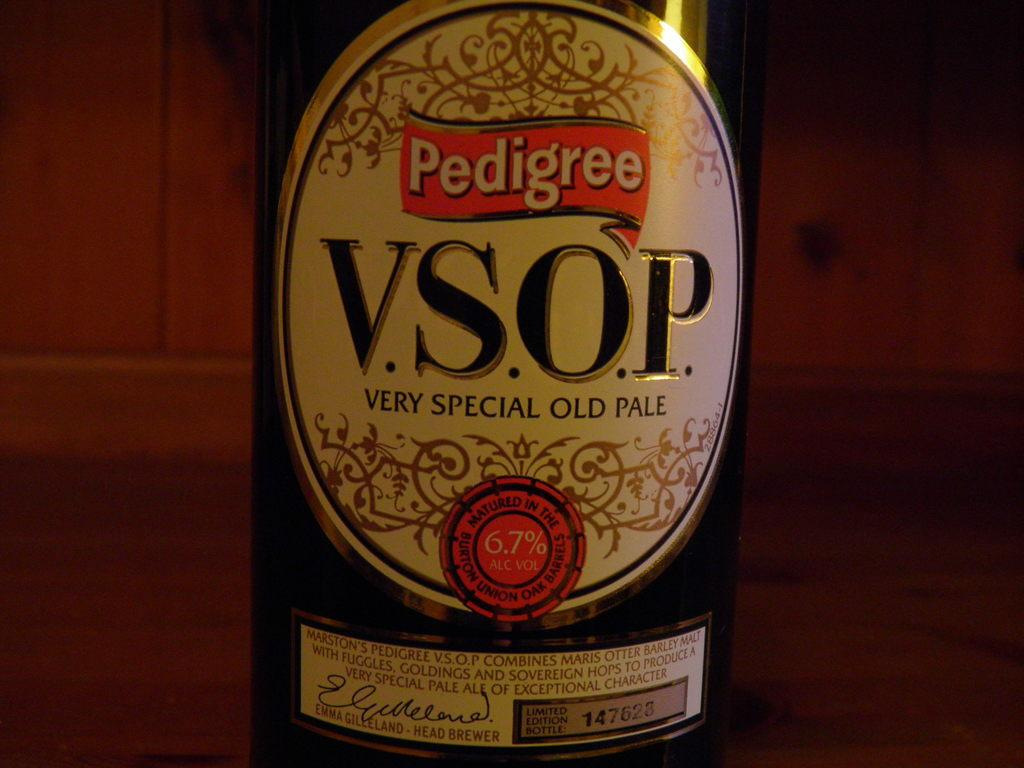<image>
Relay a brief, clear account of the picture shown. Pedigree brewery label that is a pale ale beer 